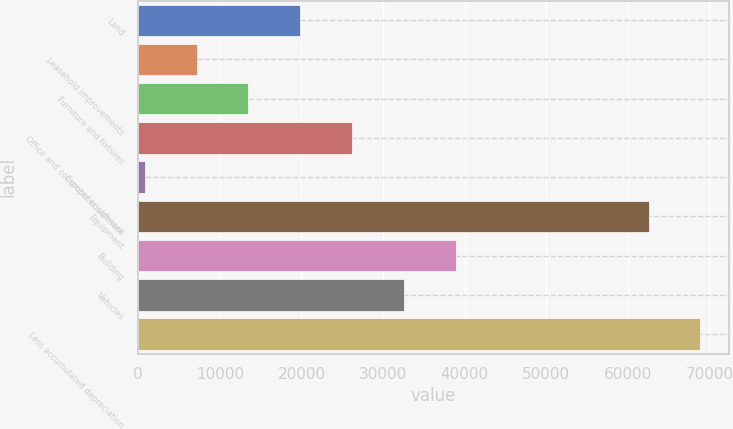Convert chart. <chart><loc_0><loc_0><loc_500><loc_500><bar_chart><fcel>Land<fcel>Leasehold improvements<fcel>Furniture and fixtures<fcel>Office and computer equipment<fcel>Computer software<fcel>Equipment<fcel>Building<fcel>Vehicles<fcel>Less accumulated depreciation<nl><fcel>19850.6<fcel>7144.2<fcel>13497.4<fcel>26203.8<fcel>791<fcel>62552<fcel>38910.2<fcel>32557<fcel>68905.2<nl></chart> 